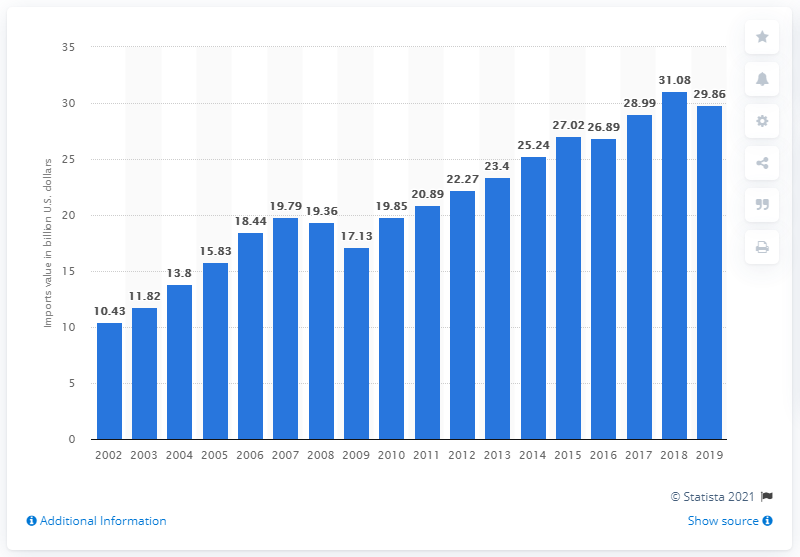Highlight a few significant elements in this photo. In 2019, the value of imports of household and kitchen appliances into the United States was 29.86... 